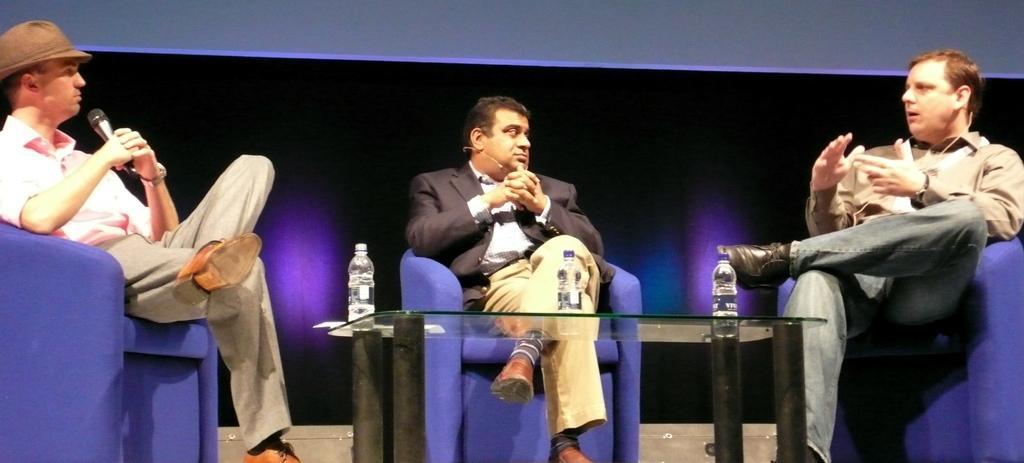Please provide a concise description of this image. In this image we can see people sitting on the chairs and we can also see bottles placed on the glass object. 